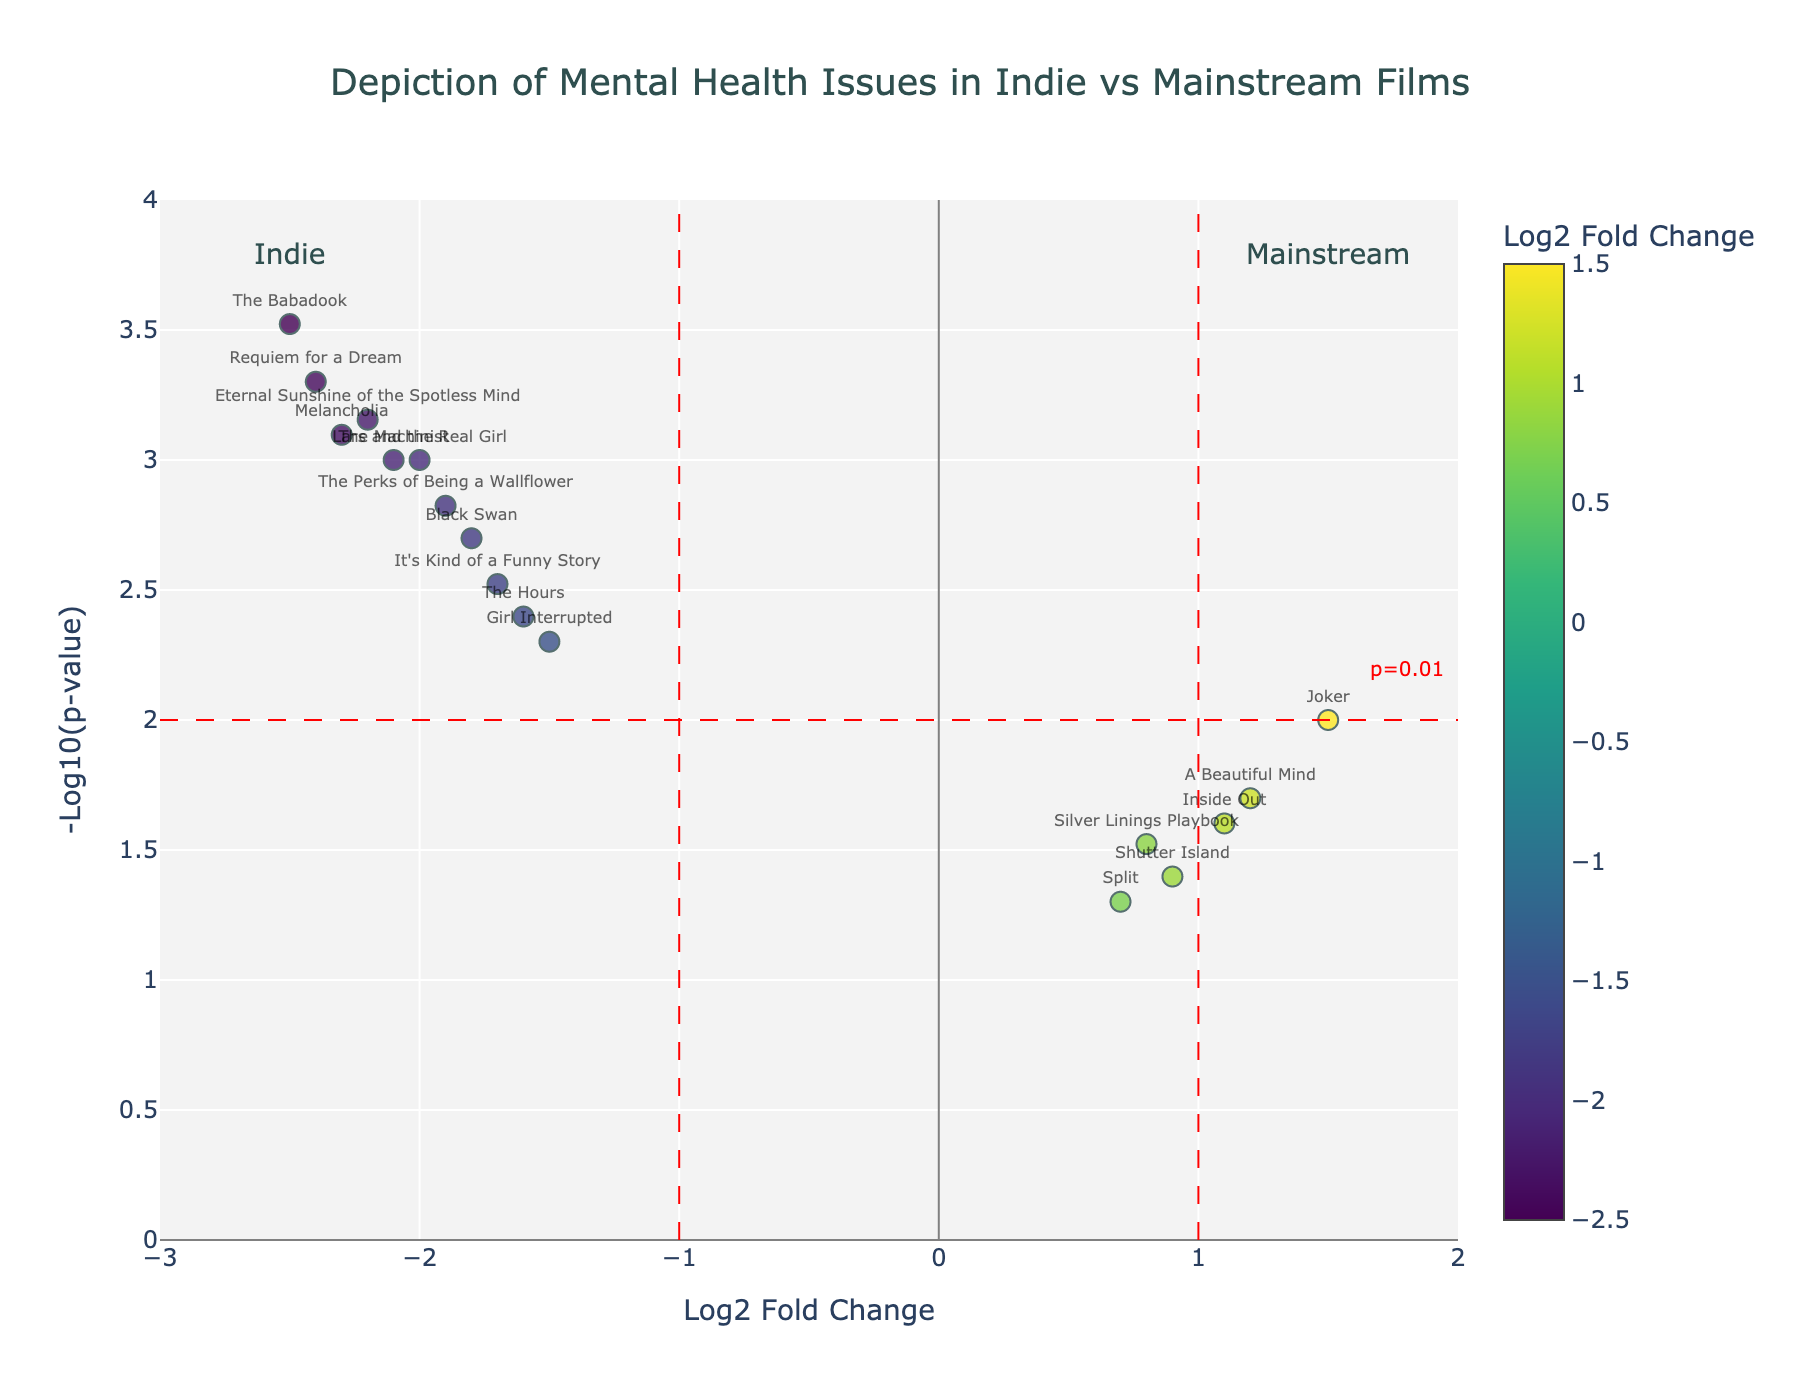How many indie films have a negative log2 fold change? Look at the x-axis for negative values and count the data points. There are 10 films with a log2 fold change less than 0.
Answer: 10 indie films Which film has the lowest p-value? Identify the film with the highest -log10(p-value) value which indicates the smallest p-value. The Babadook has the highest y-value, indicating the lowest p-value.
Answer: The Babadook What does the horizontal red dashed line represent? The horizontal red dashed line is at y=2 on the -log10(p-value) axis. This typically indicates a p-value cutoff of 0.01.
Answer: p=0.01 threshold Are there more indie films or mainstream films above the significance threshold? Count the number of data points above the horizontal red dashed line at y=2, representing significant p-values, and determine their log2 fold change directions. There are more indie films with negative log2 fold change above the threshold.
Answer: More indie films How many mainstream films have a p-value less than 0.01? Look for data points with log2 fold changes greater than 1 (mainstream films) and above the horizontal red line (p-value <0.01). There is only one film that meets this criterion.
Answer: One film Which indie film depicts mental health issues with the most negative log2 fold change? For indie films (log2 fold change <0), find the one with the most negative value on the x-axis. The Babadook has the lowest log2 fold change (-2.5).
Answer: The Babadook What is the p-value of "Inside Out"? Locate "Inside Out" on the plot and check its y-coordinate. Its -log10(p-value) is approximately 1.6, which translates to a p-value of 10^(-1.6).
Answer: 0.025 How does the depiction of mental health in "Joker" compare to that in "Black Swan"? "Joker" has a positive log2 fold change (1.5), indicating mainstream, and "Black Swan" has a negative log2 fold change (-1.8), indicating indie. Compare their y-values for significance levels. Both are significant, but in opposite directions.
Answer: "Joker" (Mainstream, p<0.01) vs "Black Swan" (Indie, p<0.01) Which films are closest to the fold change threshold? Identify films near x-values of -1 and 1. "Silver Linings Playbook" is close to 1, and "Girl Interrupted" is close to -1.
Answer: "Silver Linings Playbook" and "Girl Interrupted" 